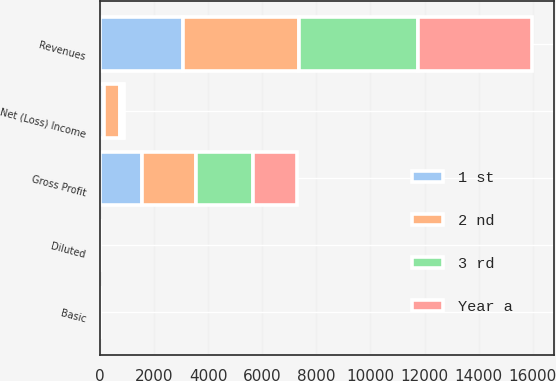Convert chart to OTSL. <chart><loc_0><loc_0><loc_500><loc_500><stacked_bar_chart><ecel><fcel>Revenues<fcel>Gross Profit<fcel>Net (Loss) Income<fcel>Basic<fcel>Diluted<nl><fcel>1 st<fcel>3080<fcel>1553<fcel>136<fcel>0.76<fcel>0.76<nl><fcel>Year a<fcel>4222<fcel>1606<fcel>12<fcel>0.19<fcel>0.19<nl><fcel>2 nd<fcel>4278<fcel>2017<fcel>594<fcel>2.08<fcel>2.03<nl><fcel>3 rd<fcel>4402<fcel>2094<fcel>135<fcel>0.64<fcel>0.64<nl></chart> 